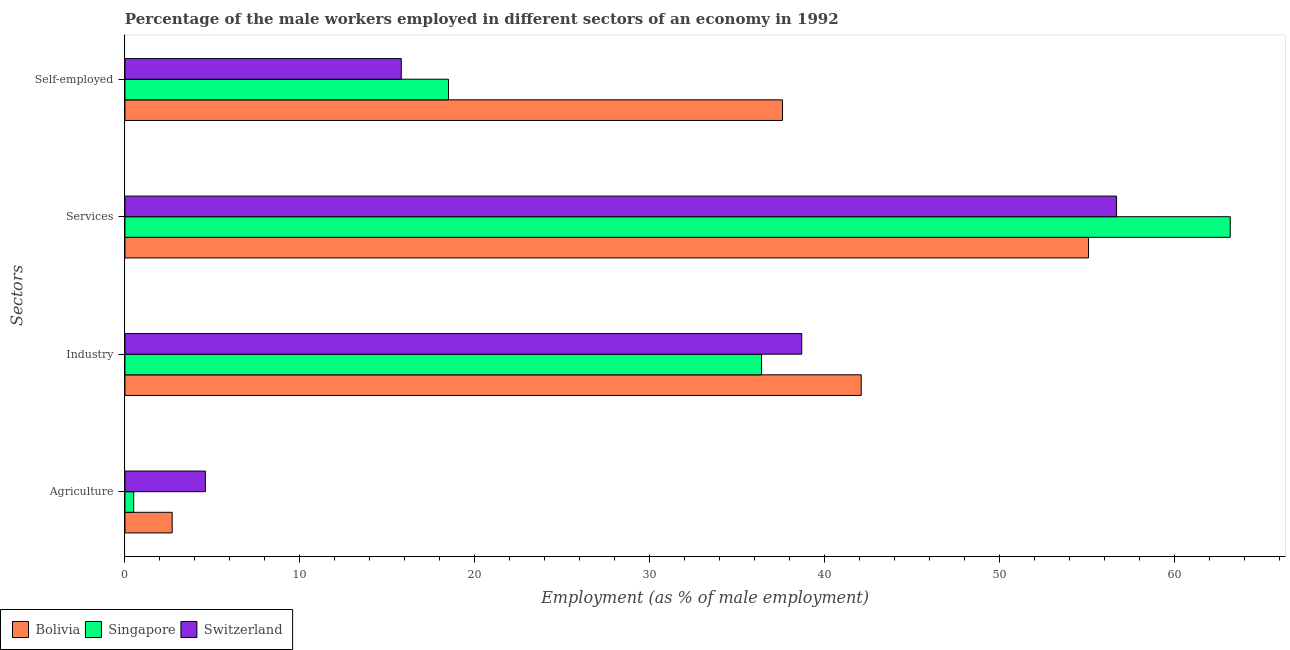How many groups of bars are there?
Your answer should be compact. 4. What is the label of the 1st group of bars from the top?
Keep it short and to the point. Self-employed. What is the percentage of male workers in services in Switzerland?
Give a very brief answer. 56.7. Across all countries, what is the maximum percentage of male workers in agriculture?
Ensure brevity in your answer.  4.6. Across all countries, what is the minimum percentage of male workers in services?
Provide a short and direct response. 55.1. In which country was the percentage of self employed male workers maximum?
Offer a terse response. Bolivia. What is the total percentage of male workers in industry in the graph?
Offer a terse response. 117.2. What is the difference between the percentage of male workers in services in Singapore and that in Switzerland?
Your answer should be very brief. 6.5. What is the difference between the percentage of male workers in services in Switzerland and the percentage of male workers in industry in Bolivia?
Give a very brief answer. 14.6. What is the average percentage of male workers in industry per country?
Make the answer very short. 39.07. What is the difference between the percentage of male workers in services and percentage of self employed male workers in Switzerland?
Offer a terse response. 40.9. In how many countries, is the percentage of self employed male workers greater than 36 %?
Provide a short and direct response. 1. What is the ratio of the percentage of male workers in services in Singapore to that in Bolivia?
Your answer should be compact. 1.15. What is the difference between the highest and the second highest percentage of male workers in agriculture?
Make the answer very short. 1.9. What is the difference between the highest and the lowest percentage of male workers in services?
Your answer should be very brief. 8.1. Is the sum of the percentage of self employed male workers in Singapore and Bolivia greater than the maximum percentage of male workers in agriculture across all countries?
Your answer should be very brief. Yes. What does the 1st bar from the bottom in Services represents?
Give a very brief answer. Bolivia. Is it the case that in every country, the sum of the percentage of male workers in agriculture and percentage of male workers in industry is greater than the percentage of male workers in services?
Provide a short and direct response. No. How many bars are there?
Keep it short and to the point. 12. How many countries are there in the graph?
Your answer should be compact. 3. Does the graph contain any zero values?
Your response must be concise. No. Does the graph contain grids?
Offer a terse response. No. Where does the legend appear in the graph?
Provide a succinct answer. Bottom left. How are the legend labels stacked?
Your answer should be very brief. Horizontal. What is the title of the graph?
Your answer should be compact. Percentage of the male workers employed in different sectors of an economy in 1992. What is the label or title of the X-axis?
Provide a short and direct response. Employment (as % of male employment). What is the label or title of the Y-axis?
Give a very brief answer. Sectors. What is the Employment (as % of male employment) in Bolivia in Agriculture?
Provide a short and direct response. 2.7. What is the Employment (as % of male employment) of Switzerland in Agriculture?
Give a very brief answer. 4.6. What is the Employment (as % of male employment) of Bolivia in Industry?
Provide a short and direct response. 42.1. What is the Employment (as % of male employment) of Singapore in Industry?
Offer a terse response. 36.4. What is the Employment (as % of male employment) of Switzerland in Industry?
Provide a short and direct response. 38.7. What is the Employment (as % of male employment) in Bolivia in Services?
Your answer should be compact. 55.1. What is the Employment (as % of male employment) in Singapore in Services?
Your response must be concise. 63.2. What is the Employment (as % of male employment) of Switzerland in Services?
Ensure brevity in your answer.  56.7. What is the Employment (as % of male employment) of Bolivia in Self-employed?
Make the answer very short. 37.6. What is the Employment (as % of male employment) in Switzerland in Self-employed?
Your response must be concise. 15.8. Across all Sectors, what is the maximum Employment (as % of male employment) of Bolivia?
Offer a very short reply. 55.1. Across all Sectors, what is the maximum Employment (as % of male employment) in Singapore?
Provide a succinct answer. 63.2. Across all Sectors, what is the maximum Employment (as % of male employment) in Switzerland?
Your response must be concise. 56.7. Across all Sectors, what is the minimum Employment (as % of male employment) in Bolivia?
Your answer should be compact. 2.7. Across all Sectors, what is the minimum Employment (as % of male employment) in Switzerland?
Keep it short and to the point. 4.6. What is the total Employment (as % of male employment) of Bolivia in the graph?
Your response must be concise. 137.5. What is the total Employment (as % of male employment) of Singapore in the graph?
Your answer should be compact. 118.6. What is the total Employment (as % of male employment) in Switzerland in the graph?
Offer a very short reply. 115.8. What is the difference between the Employment (as % of male employment) of Bolivia in Agriculture and that in Industry?
Offer a terse response. -39.4. What is the difference between the Employment (as % of male employment) in Singapore in Agriculture and that in Industry?
Offer a terse response. -35.9. What is the difference between the Employment (as % of male employment) of Switzerland in Agriculture and that in Industry?
Offer a very short reply. -34.1. What is the difference between the Employment (as % of male employment) in Bolivia in Agriculture and that in Services?
Keep it short and to the point. -52.4. What is the difference between the Employment (as % of male employment) in Singapore in Agriculture and that in Services?
Ensure brevity in your answer.  -62.7. What is the difference between the Employment (as % of male employment) in Switzerland in Agriculture and that in Services?
Offer a terse response. -52.1. What is the difference between the Employment (as % of male employment) in Bolivia in Agriculture and that in Self-employed?
Make the answer very short. -34.9. What is the difference between the Employment (as % of male employment) of Singapore in Agriculture and that in Self-employed?
Make the answer very short. -18. What is the difference between the Employment (as % of male employment) in Switzerland in Agriculture and that in Self-employed?
Offer a terse response. -11.2. What is the difference between the Employment (as % of male employment) of Singapore in Industry and that in Services?
Ensure brevity in your answer.  -26.8. What is the difference between the Employment (as % of male employment) of Switzerland in Industry and that in Self-employed?
Your answer should be compact. 22.9. What is the difference between the Employment (as % of male employment) of Singapore in Services and that in Self-employed?
Provide a short and direct response. 44.7. What is the difference between the Employment (as % of male employment) in Switzerland in Services and that in Self-employed?
Offer a very short reply. 40.9. What is the difference between the Employment (as % of male employment) in Bolivia in Agriculture and the Employment (as % of male employment) in Singapore in Industry?
Your answer should be compact. -33.7. What is the difference between the Employment (as % of male employment) in Bolivia in Agriculture and the Employment (as % of male employment) in Switzerland in Industry?
Offer a terse response. -36. What is the difference between the Employment (as % of male employment) in Singapore in Agriculture and the Employment (as % of male employment) in Switzerland in Industry?
Give a very brief answer. -38.2. What is the difference between the Employment (as % of male employment) of Bolivia in Agriculture and the Employment (as % of male employment) of Singapore in Services?
Make the answer very short. -60.5. What is the difference between the Employment (as % of male employment) of Bolivia in Agriculture and the Employment (as % of male employment) of Switzerland in Services?
Offer a very short reply. -54. What is the difference between the Employment (as % of male employment) of Singapore in Agriculture and the Employment (as % of male employment) of Switzerland in Services?
Offer a very short reply. -56.2. What is the difference between the Employment (as % of male employment) in Bolivia in Agriculture and the Employment (as % of male employment) in Singapore in Self-employed?
Keep it short and to the point. -15.8. What is the difference between the Employment (as % of male employment) of Bolivia in Agriculture and the Employment (as % of male employment) of Switzerland in Self-employed?
Your answer should be compact. -13.1. What is the difference between the Employment (as % of male employment) in Singapore in Agriculture and the Employment (as % of male employment) in Switzerland in Self-employed?
Your response must be concise. -15.3. What is the difference between the Employment (as % of male employment) in Bolivia in Industry and the Employment (as % of male employment) in Singapore in Services?
Offer a terse response. -21.1. What is the difference between the Employment (as % of male employment) of Bolivia in Industry and the Employment (as % of male employment) of Switzerland in Services?
Make the answer very short. -14.6. What is the difference between the Employment (as % of male employment) in Singapore in Industry and the Employment (as % of male employment) in Switzerland in Services?
Keep it short and to the point. -20.3. What is the difference between the Employment (as % of male employment) of Bolivia in Industry and the Employment (as % of male employment) of Singapore in Self-employed?
Provide a succinct answer. 23.6. What is the difference between the Employment (as % of male employment) in Bolivia in Industry and the Employment (as % of male employment) in Switzerland in Self-employed?
Your response must be concise. 26.3. What is the difference between the Employment (as % of male employment) of Singapore in Industry and the Employment (as % of male employment) of Switzerland in Self-employed?
Your response must be concise. 20.6. What is the difference between the Employment (as % of male employment) of Bolivia in Services and the Employment (as % of male employment) of Singapore in Self-employed?
Make the answer very short. 36.6. What is the difference between the Employment (as % of male employment) of Bolivia in Services and the Employment (as % of male employment) of Switzerland in Self-employed?
Ensure brevity in your answer.  39.3. What is the difference between the Employment (as % of male employment) of Singapore in Services and the Employment (as % of male employment) of Switzerland in Self-employed?
Offer a terse response. 47.4. What is the average Employment (as % of male employment) of Bolivia per Sectors?
Your answer should be compact. 34.38. What is the average Employment (as % of male employment) of Singapore per Sectors?
Your answer should be very brief. 29.65. What is the average Employment (as % of male employment) in Switzerland per Sectors?
Your response must be concise. 28.95. What is the difference between the Employment (as % of male employment) in Bolivia and Employment (as % of male employment) in Singapore in Agriculture?
Offer a terse response. 2.2. What is the difference between the Employment (as % of male employment) of Bolivia and Employment (as % of male employment) of Singapore in Industry?
Your answer should be compact. 5.7. What is the difference between the Employment (as % of male employment) in Bolivia and Employment (as % of male employment) in Switzerland in Industry?
Ensure brevity in your answer.  3.4. What is the difference between the Employment (as % of male employment) in Singapore and Employment (as % of male employment) in Switzerland in Industry?
Offer a terse response. -2.3. What is the difference between the Employment (as % of male employment) of Bolivia and Employment (as % of male employment) of Switzerland in Services?
Provide a short and direct response. -1.6. What is the difference between the Employment (as % of male employment) in Bolivia and Employment (as % of male employment) in Switzerland in Self-employed?
Your response must be concise. 21.8. What is the difference between the Employment (as % of male employment) in Singapore and Employment (as % of male employment) in Switzerland in Self-employed?
Your response must be concise. 2.7. What is the ratio of the Employment (as % of male employment) of Bolivia in Agriculture to that in Industry?
Keep it short and to the point. 0.06. What is the ratio of the Employment (as % of male employment) of Singapore in Agriculture to that in Industry?
Make the answer very short. 0.01. What is the ratio of the Employment (as % of male employment) in Switzerland in Agriculture to that in Industry?
Your answer should be very brief. 0.12. What is the ratio of the Employment (as % of male employment) of Bolivia in Agriculture to that in Services?
Keep it short and to the point. 0.05. What is the ratio of the Employment (as % of male employment) in Singapore in Agriculture to that in Services?
Ensure brevity in your answer.  0.01. What is the ratio of the Employment (as % of male employment) in Switzerland in Agriculture to that in Services?
Offer a terse response. 0.08. What is the ratio of the Employment (as % of male employment) in Bolivia in Agriculture to that in Self-employed?
Give a very brief answer. 0.07. What is the ratio of the Employment (as % of male employment) in Singapore in Agriculture to that in Self-employed?
Ensure brevity in your answer.  0.03. What is the ratio of the Employment (as % of male employment) of Switzerland in Agriculture to that in Self-employed?
Provide a short and direct response. 0.29. What is the ratio of the Employment (as % of male employment) in Bolivia in Industry to that in Services?
Provide a succinct answer. 0.76. What is the ratio of the Employment (as % of male employment) in Singapore in Industry to that in Services?
Provide a succinct answer. 0.58. What is the ratio of the Employment (as % of male employment) in Switzerland in Industry to that in Services?
Your answer should be very brief. 0.68. What is the ratio of the Employment (as % of male employment) in Bolivia in Industry to that in Self-employed?
Offer a terse response. 1.12. What is the ratio of the Employment (as % of male employment) in Singapore in Industry to that in Self-employed?
Make the answer very short. 1.97. What is the ratio of the Employment (as % of male employment) in Switzerland in Industry to that in Self-employed?
Your response must be concise. 2.45. What is the ratio of the Employment (as % of male employment) in Bolivia in Services to that in Self-employed?
Ensure brevity in your answer.  1.47. What is the ratio of the Employment (as % of male employment) in Singapore in Services to that in Self-employed?
Your answer should be very brief. 3.42. What is the ratio of the Employment (as % of male employment) of Switzerland in Services to that in Self-employed?
Your answer should be compact. 3.59. What is the difference between the highest and the second highest Employment (as % of male employment) of Bolivia?
Offer a terse response. 13. What is the difference between the highest and the second highest Employment (as % of male employment) of Singapore?
Make the answer very short. 26.8. What is the difference between the highest and the second highest Employment (as % of male employment) of Switzerland?
Your answer should be very brief. 18. What is the difference between the highest and the lowest Employment (as % of male employment) in Bolivia?
Offer a very short reply. 52.4. What is the difference between the highest and the lowest Employment (as % of male employment) of Singapore?
Provide a short and direct response. 62.7. What is the difference between the highest and the lowest Employment (as % of male employment) in Switzerland?
Provide a succinct answer. 52.1. 